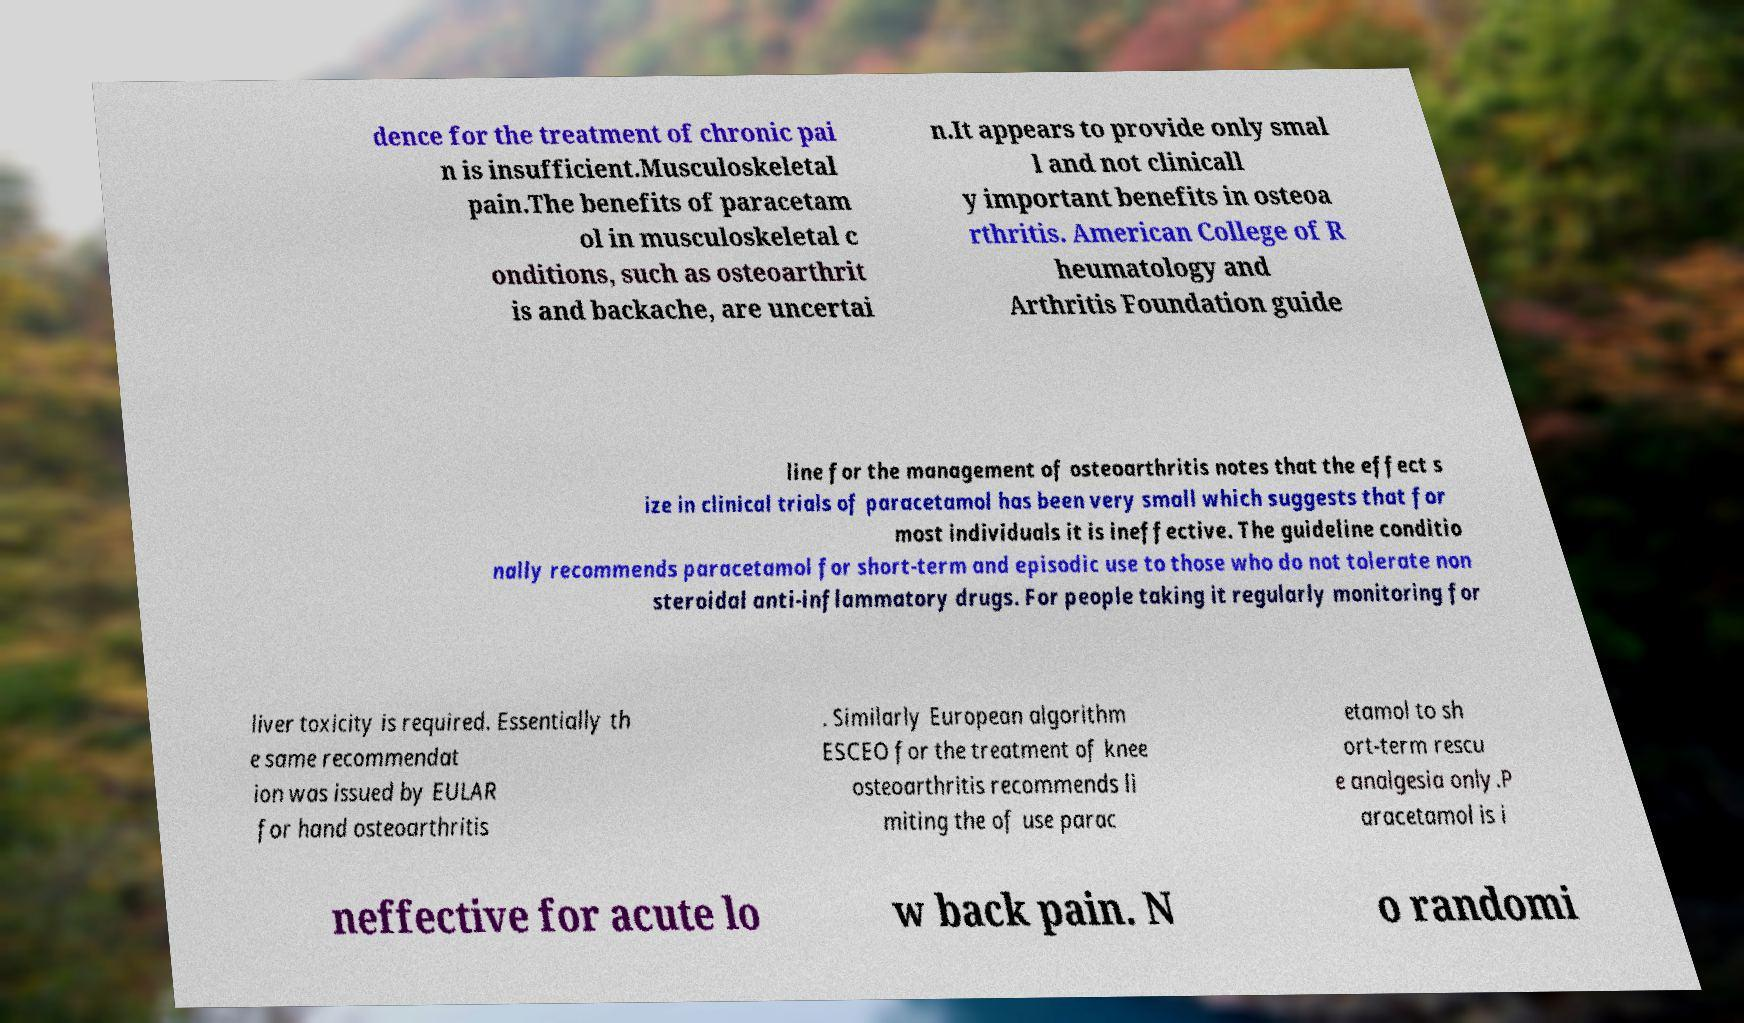Could you assist in decoding the text presented in this image and type it out clearly? dence for the treatment of chronic pai n is insufficient.Musculoskeletal pain.The benefits of paracetam ol in musculoskeletal c onditions, such as osteoarthrit is and backache, are uncertai n.It appears to provide only smal l and not clinicall y important benefits in osteoa rthritis. American College of R heumatology and Arthritis Foundation guide line for the management of osteoarthritis notes that the effect s ize in clinical trials of paracetamol has been very small which suggests that for most individuals it is ineffective. The guideline conditio nally recommends paracetamol for short-term and episodic use to those who do not tolerate non steroidal anti-inflammatory drugs. For people taking it regularly monitoring for liver toxicity is required. Essentially th e same recommendat ion was issued by EULAR for hand osteoarthritis . Similarly European algorithm ESCEO for the treatment of knee osteoarthritis recommends li miting the of use parac etamol to sh ort-term rescu e analgesia only.P aracetamol is i neffective for acute lo w back pain. N o randomi 